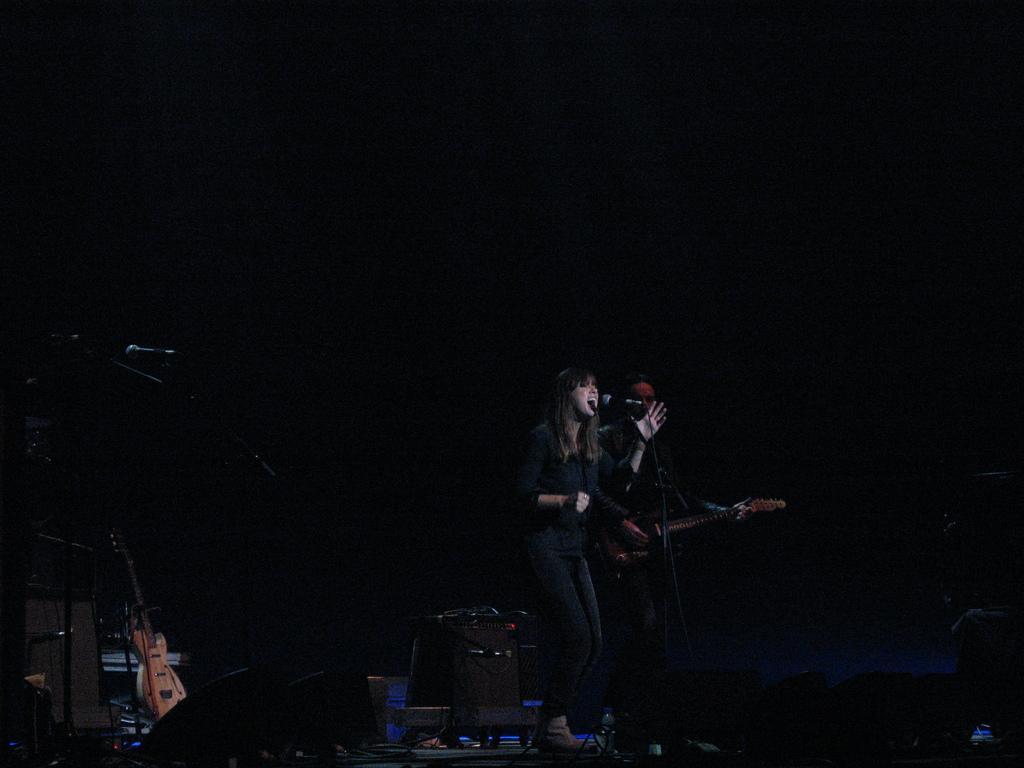Please provide a concise description of this image. In this image a lady is singing. In front of her there is a mic. Beside her a person is playing guitar. There are mics, guitar and few other things on the floor. 